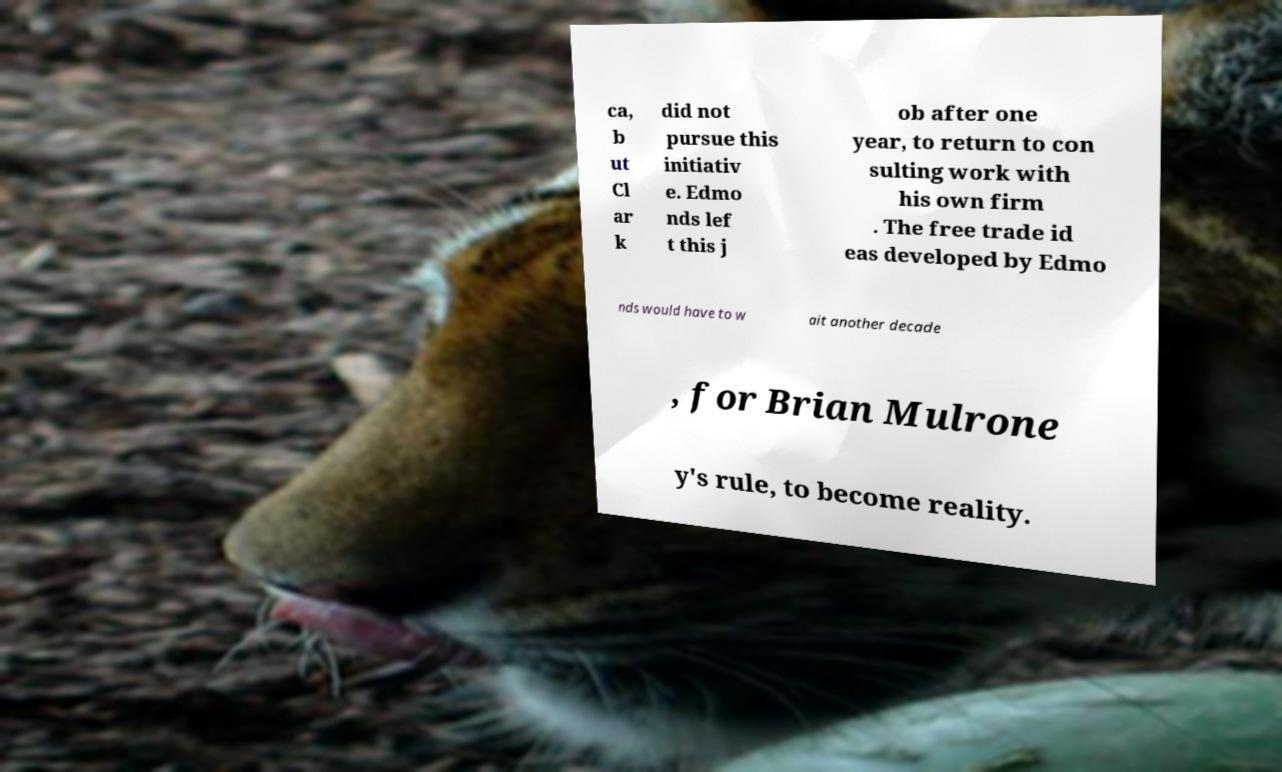There's text embedded in this image that I need extracted. Can you transcribe it verbatim? ca, b ut Cl ar k did not pursue this initiativ e. Edmo nds lef t this j ob after one year, to return to con sulting work with his own firm . The free trade id eas developed by Edmo nds would have to w ait another decade , for Brian Mulrone y's rule, to become reality. 